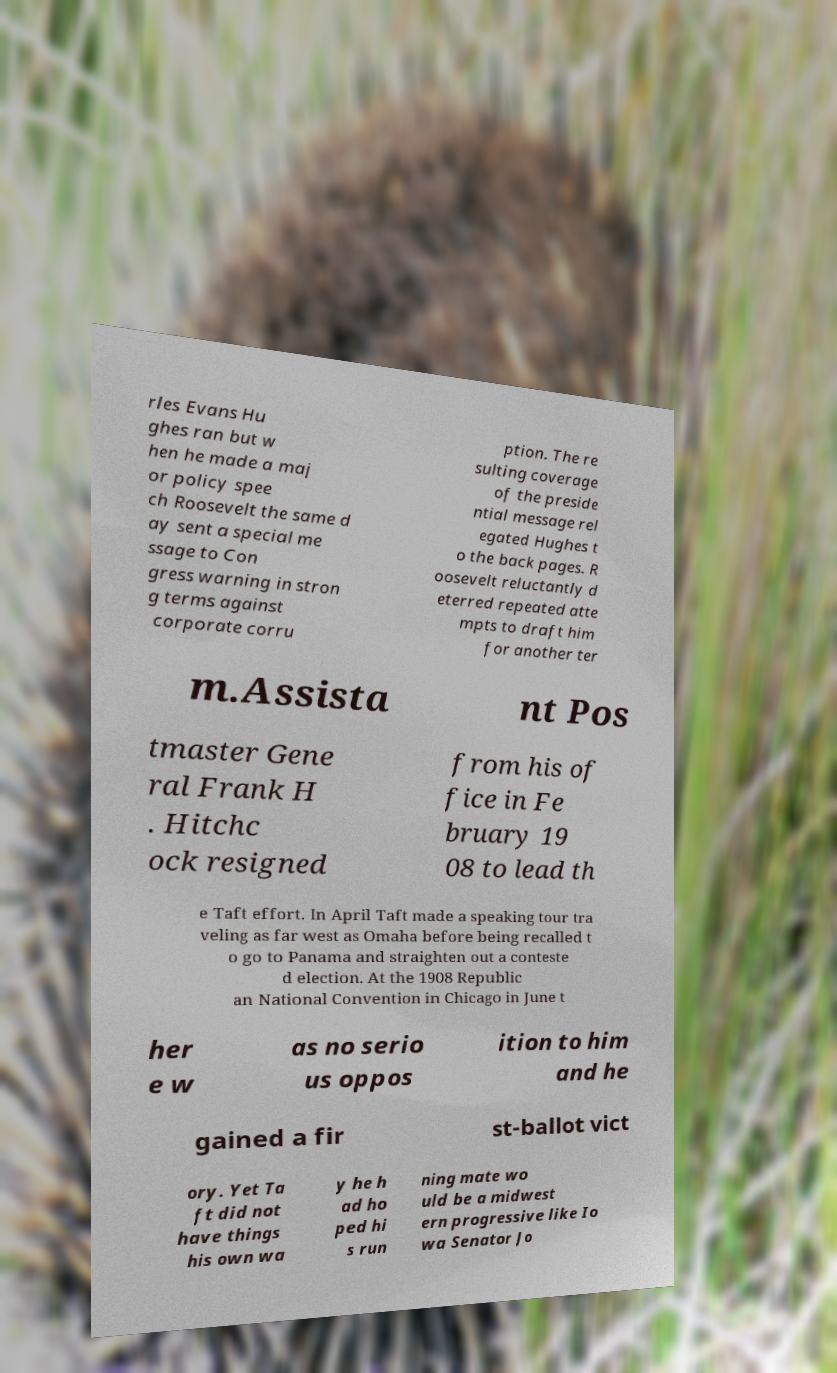Can you accurately transcribe the text from the provided image for me? rles Evans Hu ghes ran but w hen he made a maj or policy spee ch Roosevelt the same d ay sent a special me ssage to Con gress warning in stron g terms against corporate corru ption. The re sulting coverage of the preside ntial message rel egated Hughes t o the back pages. R oosevelt reluctantly d eterred repeated atte mpts to draft him for another ter m.Assista nt Pos tmaster Gene ral Frank H . Hitchc ock resigned from his of fice in Fe bruary 19 08 to lead th e Taft effort. In April Taft made a speaking tour tra veling as far west as Omaha before being recalled t o go to Panama and straighten out a conteste d election. At the 1908 Republic an National Convention in Chicago in June t her e w as no serio us oppos ition to him and he gained a fir st-ballot vict ory. Yet Ta ft did not have things his own wa y he h ad ho ped hi s run ning mate wo uld be a midwest ern progressive like Io wa Senator Jo 